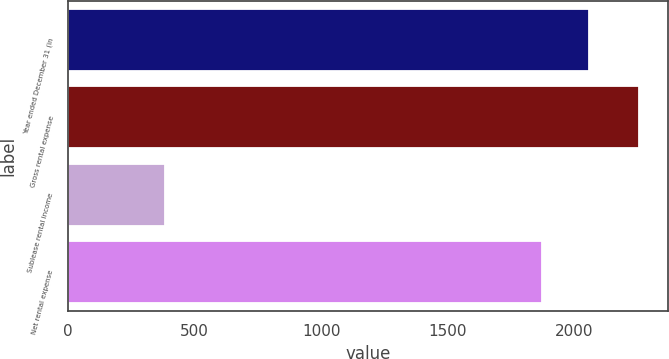Convert chart to OTSL. <chart><loc_0><loc_0><loc_500><loc_500><bar_chart><fcel>Year ended December 31 (in<fcel>Gross rental expense<fcel>Sublease rental income<fcel>Net rental expense<nl><fcel>2059.2<fcel>2255<fcel>383<fcel>1872<nl></chart> 